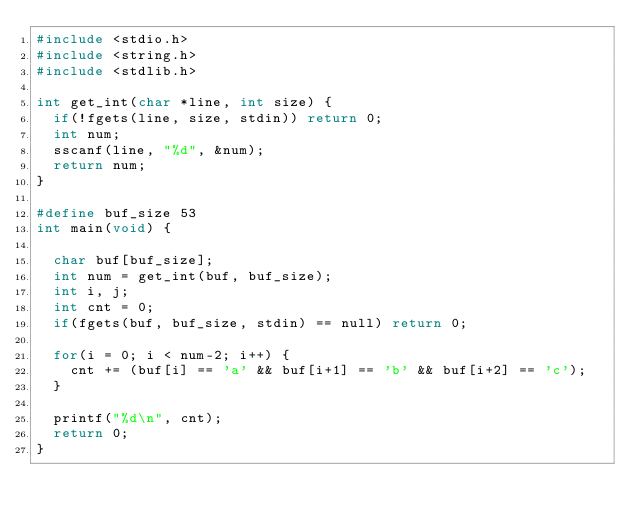<code> <loc_0><loc_0><loc_500><loc_500><_C_>#include <stdio.h>
#include <string.h>
#include <stdlib.h>

int get_int(char *line, int size) {
  if(!fgets(line, size, stdin)) return 0;
  int num;
  sscanf(line, "%d", &num);
  return num;
}

#define buf_size 53
int main(void) {

  char buf[buf_size];
  int num = get_int(buf, buf_size);
  int i, j;
  int cnt = 0;
  if(fgets(buf, buf_size, stdin) == null) return 0;

  for(i = 0; i < num-2; i++) {
    cnt += (buf[i] == 'a' && buf[i+1] == 'b' && buf[i+2] == 'c');
  }

  printf("%d\n", cnt);
  return 0;
}
</code> 